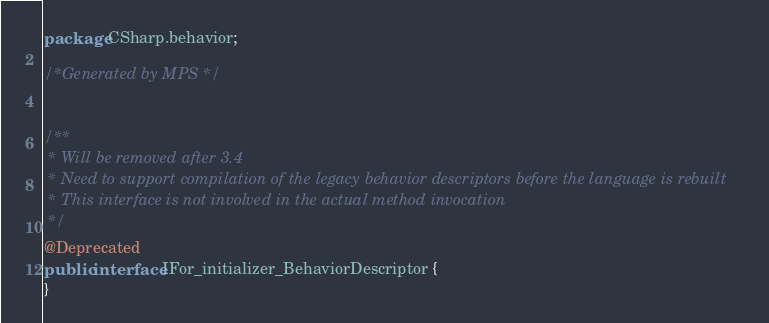<code> <loc_0><loc_0><loc_500><loc_500><_Java_>package CSharp.behavior;

/*Generated by MPS */


/**
 * Will be removed after 3.4
 * Need to support compilation of the legacy behavior descriptors before the language is rebuilt
 * This interface is not involved in the actual method invocation
 */
@Deprecated
public interface IFor_initializer_BehaviorDescriptor {
}
</code> 